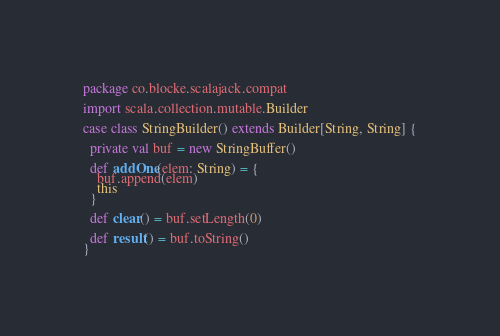<code> <loc_0><loc_0><loc_500><loc_500><_Scala_>package co.blocke.scalajack.compat

import scala.collection.mutable.Builder

case class StringBuilder() extends Builder[String, String] {

  private val buf = new StringBuffer()

  def addOne(elem: String) = {
    buf.append(elem)
    this
  }

  def clear() = buf.setLength(0)

  def result() = buf.toString()
}
</code> 